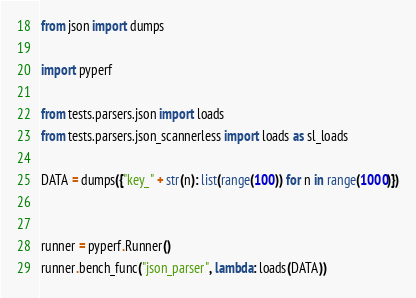Convert code to text. <code><loc_0><loc_0><loc_500><loc_500><_Python_>from json import dumps

import pyperf

from tests.parsers.json import loads
from tests.parsers.json_scannerless import loads as sl_loads

DATA = dumps({"key_" + str(n): list(range(100)) for n in range(1000)})


runner = pyperf.Runner()
runner.bench_func("json_parser", lambda: loads(DATA))</code> 